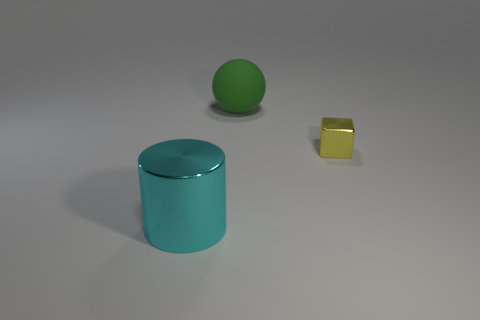Add 3 tiny cubes. How many objects exist? 6 Subtract all spheres. How many objects are left? 2 Add 3 green metallic spheres. How many green metallic spheres exist? 3 Subtract 0 brown cylinders. How many objects are left? 3 Subtract all cyan metallic blocks. Subtract all spheres. How many objects are left? 2 Add 1 cyan cylinders. How many cyan cylinders are left? 2 